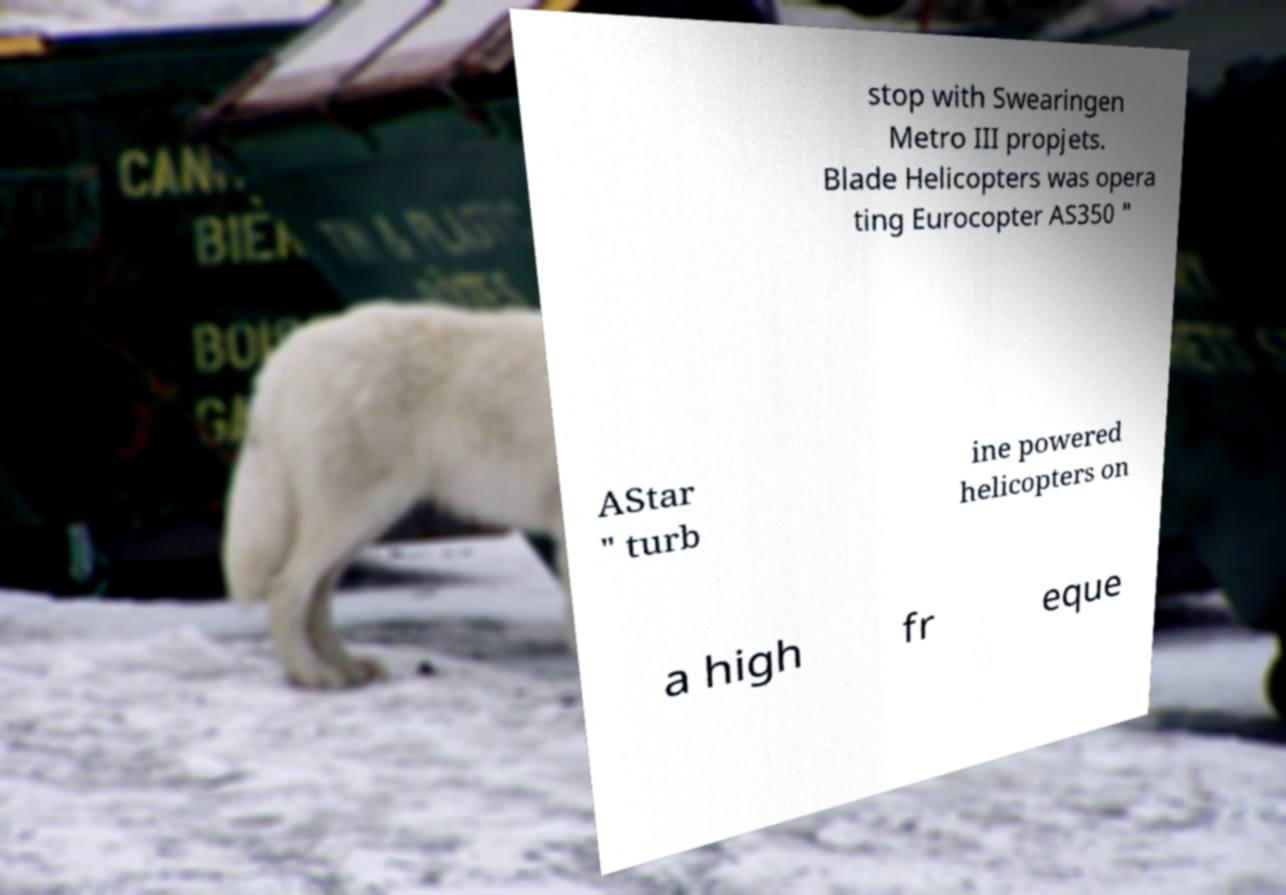Can you read and provide the text displayed in the image?This photo seems to have some interesting text. Can you extract and type it out for me? stop with Swearingen Metro III propjets. Blade Helicopters was opera ting Eurocopter AS350 " AStar " turb ine powered helicopters on a high fr eque 